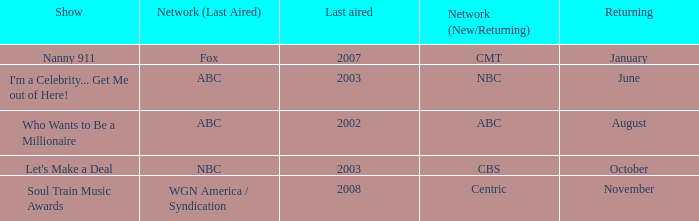When did a show last aired in 2002 return? August. 